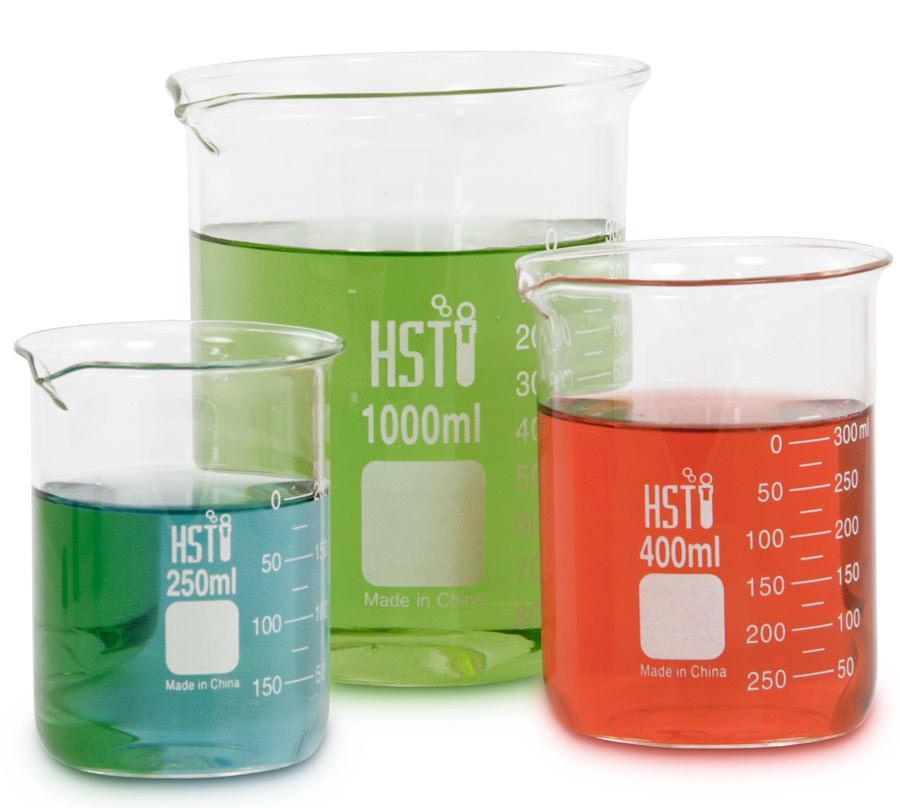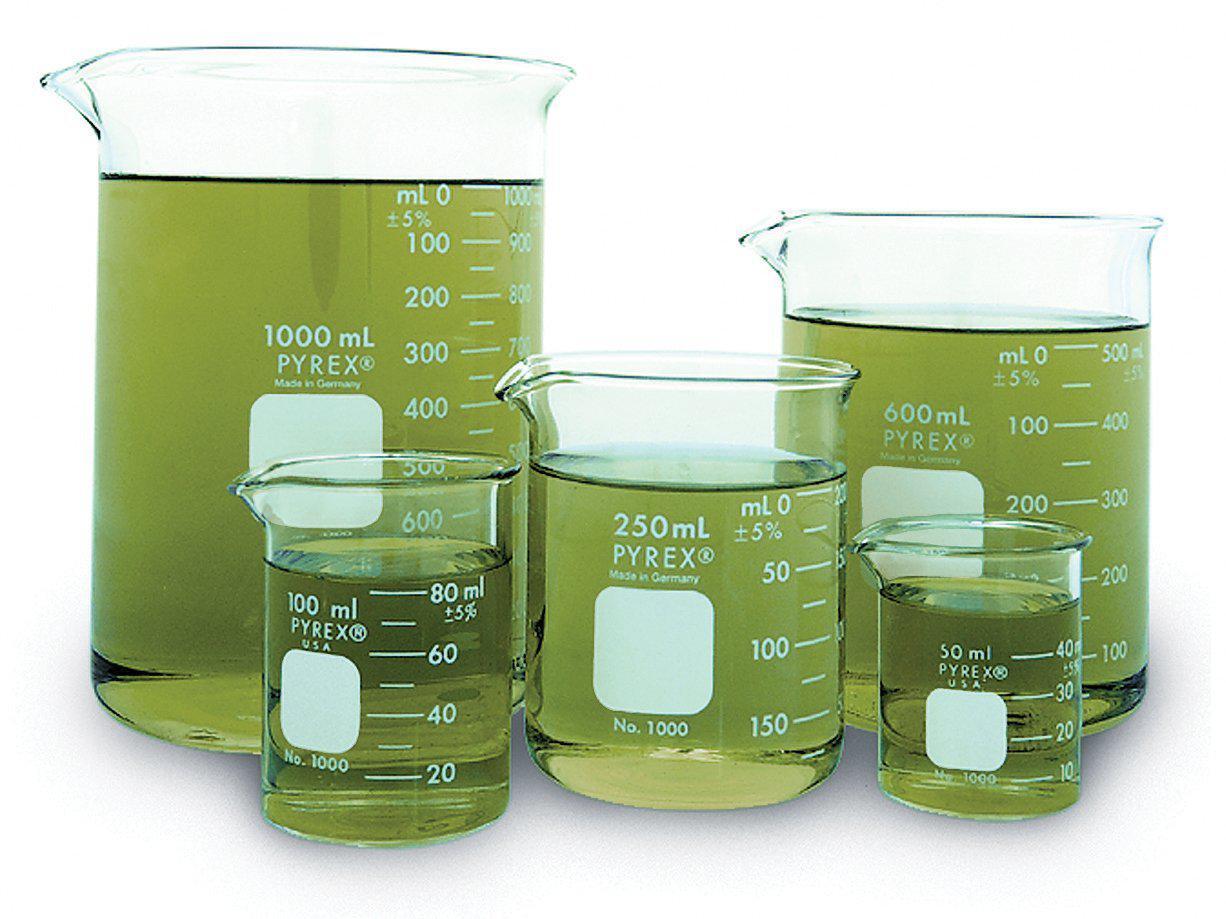The first image is the image on the left, the second image is the image on the right. Evaluate the accuracy of this statement regarding the images: "Two beakers contain red liquid.". Is it true? Answer yes or no. No. The first image is the image on the left, the second image is the image on the right. Given the left and right images, does the statement "Each image shows a group of overlapping beakers, all containing colored liquid." hold true? Answer yes or no. Yes. 